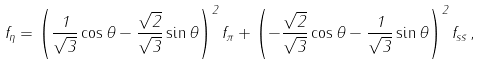<formula> <loc_0><loc_0><loc_500><loc_500>f _ { \eta } = \left ( \frac { 1 } { \sqrt { 3 } } \cos \theta - \frac { \sqrt { 2 } } { \sqrt { 3 } } \sin \theta \right ) ^ { 2 } f _ { \pi } + \left ( - \frac { \sqrt { 2 } } { \sqrt { 3 } } \cos \theta - \frac { 1 } { \sqrt { 3 } } \sin \theta \right ) ^ { 2 } f _ { s \bar { s } } \, ,</formula> 